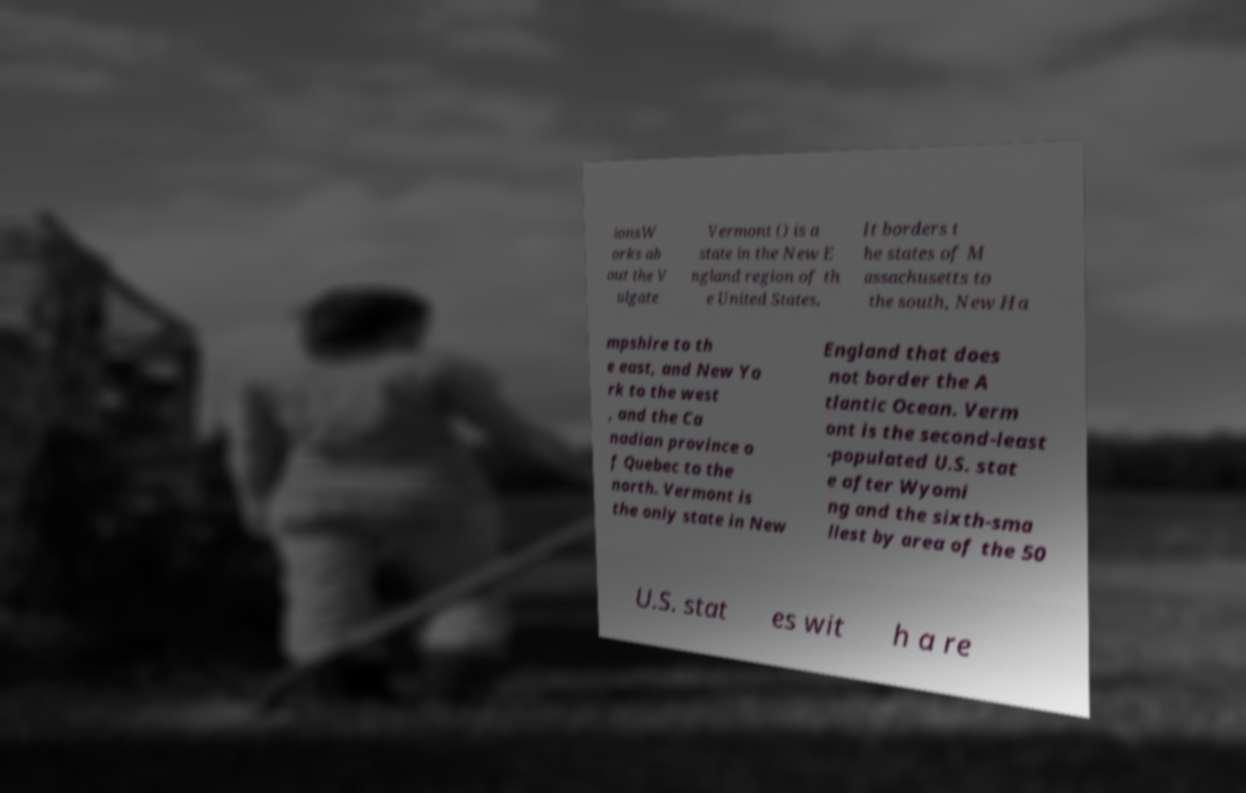Could you assist in decoding the text presented in this image and type it out clearly? ionsW orks ab out the V ulgate Vermont () is a state in the New E ngland region of th e United States. It borders t he states of M assachusetts to the south, New Ha mpshire to th e east, and New Yo rk to the west , and the Ca nadian province o f Quebec to the north. Vermont is the only state in New England that does not border the A tlantic Ocean. Verm ont is the second-least -populated U.S. stat e after Wyomi ng and the sixth-sma llest by area of the 50 U.S. stat es wit h a re 